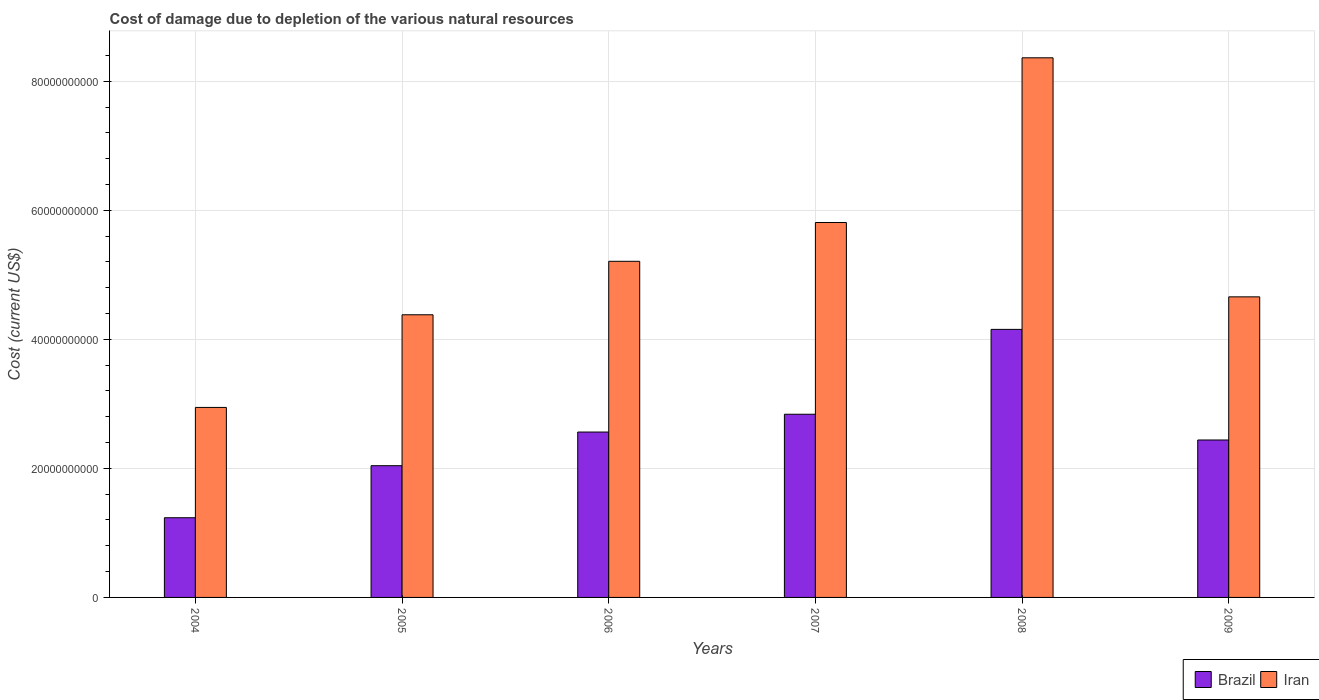How many bars are there on the 5th tick from the left?
Provide a succinct answer. 2. What is the label of the 2nd group of bars from the left?
Offer a terse response. 2005. In how many cases, is the number of bars for a given year not equal to the number of legend labels?
Offer a terse response. 0. What is the cost of damage caused due to the depletion of various natural resources in Brazil in 2008?
Your answer should be very brief. 4.15e+1. Across all years, what is the maximum cost of damage caused due to the depletion of various natural resources in Iran?
Offer a very short reply. 8.36e+1. Across all years, what is the minimum cost of damage caused due to the depletion of various natural resources in Iran?
Your answer should be very brief. 2.94e+1. In which year was the cost of damage caused due to the depletion of various natural resources in Iran maximum?
Give a very brief answer. 2008. What is the total cost of damage caused due to the depletion of various natural resources in Brazil in the graph?
Make the answer very short. 1.53e+11. What is the difference between the cost of damage caused due to the depletion of various natural resources in Iran in 2005 and that in 2009?
Your answer should be compact. -2.78e+09. What is the difference between the cost of damage caused due to the depletion of various natural resources in Brazil in 2005 and the cost of damage caused due to the depletion of various natural resources in Iran in 2006?
Your answer should be very brief. -3.17e+1. What is the average cost of damage caused due to the depletion of various natural resources in Iran per year?
Ensure brevity in your answer.  5.23e+1. In the year 2006, what is the difference between the cost of damage caused due to the depletion of various natural resources in Brazil and cost of damage caused due to the depletion of various natural resources in Iran?
Offer a very short reply. -2.65e+1. In how many years, is the cost of damage caused due to the depletion of various natural resources in Iran greater than 28000000000 US$?
Make the answer very short. 6. What is the ratio of the cost of damage caused due to the depletion of various natural resources in Brazil in 2006 to that in 2008?
Provide a succinct answer. 0.62. What is the difference between the highest and the second highest cost of damage caused due to the depletion of various natural resources in Iran?
Offer a terse response. 2.55e+1. What is the difference between the highest and the lowest cost of damage caused due to the depletion of various natural resources in Brazil?
Offer a terse response. 2.92e+1. What does the 2nd bar from the right in 2009 represents?
Keep it short and to the point. Brazil. How many bars are there?
Your response must be concise. 12. How many years are there in the graph?
Ensure brevity in your answer.  6. What is the difference between two consecutive major ticks on the Y-axis?
Make the answer very short. 2.00e+1. Are the values on the major ticks of Y-axis written in scientific E-notation?
Your answer should be compact. No. Does the graph contain any zero values?
Ensure brevity in your answer.  No. How are the legend labels stacked?
Provide a short and direct response. Horizontal. What is the title of the graph?
Your answer should be very brief. Cost of damage due to depletion of the various natural resources. What is the label or title of the X-axis?
Your response must be concise. Years. What is the label or title of the Y-axis?
Provide a short and direct response. Cost (current US$). What is the Cost (current US$) of Brazil in 2004?
Offer a very short reply. 1.24e+1. What is the Cost (current US$) of Iran in 2004?
Your response must be concise. 2.94e+1. What is the Cost (current US$) in Brazil in 2005?
Keep it short and to the point. 2.04e+1. What is the Cost (current US$) of Iran in 2005?
Make the answer very short. 4.38e+1. What is the Cost (current US$) of Brazil in 2006?
Your answer should be compact. 2.56e+1. What is the Cost (current US$) in Iran in 2006?
Your answer should be compact. 5.21e+1. What is the Cost (current US$) of Brazil in 2007?
Your answer should be compact. 2.84e+1. What is the Cost (current US$) in Iran in 2007?
Your answer should be compact. 5.81e+1. What is the Cost (current US$) in Brazil in 2008?
Offer a terse response. 4.15e+1. What is the Cost (current US$) in Iran in 2008?
Your response must be concise. 8.36e+1. What is the Cost (current US$) of Brazil in 2009?
Provide a succinct answer. 2.44e+1. What is the Cost (current US$) in Iran in 2009?
Make the answer very short. 4.66e+1. Across all years, what is the maximum Cost (current US$) of Brazil?
Offer a very short reply. 4.15e+1. Across all years, what is the maximum Cost (current US$) in Iran?
Ensure brevity in your answer.  8.36e+1. Across all years, what is the minimum Cost (current US$) of Brazil?
Keep it short and to the point. 1.24e+1. Across all years, what is the minimum Cost (current US$) of Iran?
Offer a very short reply. 2.94e+1. What is the total Cost (current US$) in Brazil in the graph?
Offer a terse response. 1.53e+11. What is the total Cost (current US$) in Iran in the graph?
Keep it short and to the point. 3.14e+11. What is the difference between the Cost (current US$) in Brazil in 2004 and that in 2005?
Your response must be concise. -8.07e+09. What is the difference between the Cost (current US$) in Iran in 2004 and that in 2005?
Offer a very short reply. -1.44e+1. What is the difference between the Cost (current US$) in Brazil in 2004 and that in 2006?
Make the answer very short. -1.33e+1. What is the difference between the Cost (current US$) in Iran in 2004 and that in 2006?
Your answer should be compact. -2.26e+1. What is the difference between the Cost (current US$) of Brazil in 2004 and that in 2007?
Ensure brevity in your answer.  -1.60e+1. What is the difference between the Cost (current US$) of Iran in 2004 and that in 2007?
Your answer should be very brief. -2.87e+1. What is the difference between the Cost (current US$) in Brazil in 2004 and that in 2008?
Offer a terse response. -2.92e+1. What is the difference between the Cost (current US$) in Iran in 2004 and that in 2008?
Offer a very short reply. -5.42e+1. What is the difference between the Cost (current US$) in Brazil in 2004 and that in 2009?
Your response must be concise. -1.20e+1. What is the difference between the Cost (current US$) of Iran in 2004 and that in 2009?
Offer a terse response. -1.71e+1. What is the difference between the Cost (current US$) in Brazil in 2005 and that in 2006?
Make the answer very short. -5.22e+09. What is the difference between the Cost (current US$) in Iran in 2005 and that in 2006?
Provide a short and direct response. -8.29e+09. What is the difference between the Cost (current US$) in Brazil in 2005 and that in 2007?
Provide a succinct answer. -7.97e+09. What is the difference between the Cost (current US$) of Iran in 2005 and that in 2007?
Ensure brevity in your answer.  -1.43e+1. What is the difference between the Cost (current US$) of Brazil in 2005 and that in 2008?
Make the answer very short. -2.11e+1. What is the difference between the Cost (current US$) in Iran in 2005 and that in 2008?
Give a very brief answer. -3.98e+1. What is the difference between the Cost (current US$) in Brazil in 2005 and that in 2009?
Your answer should be very brief. -3.98e+09. What is the difference between the Cost (current US$) in Iran in 2005 and that in 2009?
Make the answer very short. -2.78e+09. What is the difference between the Cost (current US$) of Brazil in 2006 and that in 2007?
Give a very brief answer. -2.76e+09. What is the difference between the Cost (current US$) of Iran in 2006 and that in 2007?
Provide a succinct answer. -6.01e+09. What is the difference between the Cost (current US$) of Brazil in 2006 and that in 2008?
Offer a very short reply. -1.59e+1. What is the difference between the Cost (current US$) in Iran in 2006 and that in 2008?
Provide a short and direct response. -3.15e+1. What is the difference between the Cost (current US$) in Brazil in 2006 and that in 2009?
Keep it short and to the point. 1.23e+09. What is the difference between the Cost (current US$) of Iran in 2006 and that in 2009?
Your response must be concise. 5.51e+09. What is the difference between the Cost (current US$) in Brazil in 2007 and that in 2008?
Your answer should be very brief. -1.32e+1. What is the difference between the Cost (current US$) of Iran in 2007 and that in 2008?
Your answer should be compact. -2.55e+1. What is the difference between the Cost (current US$) of Brazil in 2007 and that in 2009?
Your answer should be very brief. 3.99e+09. What is the difference between the Cost (current US$) of Iran in 2007 and that in 2009?
Offer a terse response. 1.15e+1. What is the difference between the Cost (current US$) of Brazil in 2008 and that in 2009?
Ensure brevity in your answer.  1.71e+1. What is the difference between the Cost (current US$) in Iran in 2008 and that in 2009?
Offer a terse response. 3.70e+1. What is the difference between the Cost (current US$) in Brazil in 2004 and the Cost (current US$) in Iran in 2005?
Provide a short and direct response. -3.15e+1. What is the difference between the Cost (current US$) of Brazil in 2004 and the Cost (current US$) of Iran in 2006?
Make the answer very short. -3.97e+1. What is the difference between the Cost (current US$) of Brazil in 2004 and the Cost (current US$) of Iran in 2007?
Provide a short and direct response. -4.58e+1. What is the difference between the Cost (current US$) in Brazil in 2004 and the Cost (current US$) in Iran in 2008?
Your answer should be very brief. -7.13e+1. What is the difference between the Cost (current US$) in Brazil in 2004 and the Cost (current US$) in Iran in 2009?
Make the answer very short. -3.42e+1. What is the difference between the Cost (current US$) of Brazil in 2005 and the Cost (current US$) of Iran in 2006?
Provide a short and direct response. -3.17e+1. What is the difference between the Cost (current US$) in Brazil in 2005 and the Cost (current US$) in Iran in 2007?
Your answer should be very brief. -3.77e+1. What is the difference between the Cost (current US$) in Brazil in 2005 and the Cost (current US$) in Iran in 2008?
Give a very brief answer. -6.32e+1. What is the difference between the Cost (current US$) in Brazil in 2005 and the Cost (current US$) in Iran in 2009?
Provide a succinct answer. -2.62e+1. What is the difference between the Cost (current US$) of Brazil in 2006 and the Cost (current US$) of Iran in 2007?
Provide a short and direct response. -3.25e+1. What is the difference between the Cost (current US$) in Brazil in 2006 and the Cost (current US$) in Iran in 2008?
Provide a succinct answer. -5.80e+1. What is the difference between the Cost (current US$) of Brazil in 2006 and the Cost (current US$) of Iran in 2009?
Provide a succinct answer. -2.09e+1. What is the difference between the Cost (current US$) of Brazil in 2007 and the Cost (current US$) of Iran in 2008?
Provide a short and direct response. -5.52e+1. What is the difference between the Cost (current US$) of Brazil in 2007 and the Cost (current US$) of Iran in 2009?
Your answer should be compact. -1.82e+1. What is the difference between the Cost (current US$) of Brazil in 2008 and the Cost (current US$) of Iran in 2009?
Offer a very short reply. -5.04e+09. What is the average Cost (current US$) of Brazil per year?
Your answer should be very brief. 2.55e+1. What is the average Cost (current US$) in Iran per year?
Offer a very short reply. 5.23e+1. In the year 2004, what is the difference between the Cost (current US$) in Brazil and Cost (current US$) in Iran?
Provide a succinct answer. -1.71e+1. In the year 2005, what is the difference between the Cost (current US$) in Brazil and Cost (current US$) in Iran?
Offer a terse response. -2.34e+1. In the year 2006, what is the difference between the Cost (current US$) in Brazil and Cost (current US$) in Iran?
Give a very brief answer. -2.65e+1. In the year 2007, what is the difference between the Cost (current US$) in Brazil and Cost (current US$) in Iran?
Keep it short and to the point. -2.97e+1. In the year 2008, what is the difference between the Cost (current US$) of Brazil and Cost (current US$) of Iran?
Ensure brevity in your answer.  -4.21e+1. In the year 2009, what is the difference between the Cost (current US$) of Brazil and Cost (current US$) of Iran?
Keep it short and to the point. -2.22e+1. What is the ratio of the Cost (current US$) of Brazil in 2004 to that in 2005?
Your answer should be very brief. 0.6. What is the ratio of the Cost (current US$) of Iran in 2004 to that in 2005?
Provide a succinct answer. 0.67. What is the ratio of the Cost (current US$) of Brazil in 2004 to that in 2006?
Keep it short and to the point. 0.48. What is the ratio of the Cost (current US$) in Iran in 2004 to that in 2006?
Provide a succinct answer. 0.57. What is the ratio of the Cost (current US$) in Brazil in 2004 to that in 2007?
Keep it short and to the point. 0.43. What is the ratio of the Cost (current US$) of Iran in 2004 to that in 2007?
Offer a terse response. 0.51. What is the ratio of the Cost (current US$) in Brazil in 2004 to that in 2008?
Keep it short and to the point. 0.3. What is the ratio of the Cost (current US$) of Iran in 2004 to that in 2008?
Ensure brevity in your answer.  0.35. What is the ratio of the Cost (current US$) in Brazil in 2004 to that in 2009?
Provide a succinct answer. 0.51. What is the ratio of the Cost (current US$) of Iran in 2004 to that in 2009?
Offer a terse response. 0.63. What is the ratio of the Cost (current US$) of Brazil in 2005 to that in 2006?
Provide a succinct answer. 0.8. What is the ratio of the Cost (current US$) of Iran in 2005 to that in 2006?
Give a very brief answer. 0.84. What is the ratio of the Cost (current US$) of Brazil in 2005 to that in 2007?
Offer a very short reply. 0.72. What is the ratio of the Cost (current US$) in Iran in 2005 to that in 2007?
Offer a terse response. 0.75. What is the ratio of the Cost (current US$) in Brazil in 2005 to that in 2008?
Ensure brevity in your answer.  0.49. What is the ratio of the Cost (current US$) of Iran in 2005 to that in 2008?
Your answer should be compact. 0.52. What is the ratio of the Cost (current US$) of Brazil in 2005 to that in 2009?
Ensure brevity in your answer.  0.84. What is the ratio of the Cost (current US$) in Iran in 2005 to that in 2009?
Your answer should be very brief. 0.94. What is the ratio of the Cost (current US$) in Brazil in 2006 to that in 2007?
Make the answer very short. 0.9. What is the ratio of the Cost (current US$) in Iran in 2006 to that in 2007?
Offer a terse response. 0.9. What is the ratio of the Cost (current US$) in Brazil in 2006 to that in 2008?
Ensure brevity in your answer.  0.62. What is the ratio of the Cost (current US$) of Iran in 2006 to that in 2008?
Your response must be concise. 0.62. What is the ratio of the Cost (current US$) of Brazil in 2006 to that in 2009?
Offer a terse response. 1.05. What is the ratio of the Cost (current US$) in Iran in 2006 to that in 2009?
Ensure brevity in your answer.  1.12. What is the ratio of the Cost (current US$) in Brazil in 2007 to that in 2008?
Provide a succinct answer. 0.68. What is the ratio of the Cost (current US$) of Iran in 2007 to that in 2008?
Make the answer very short. 0.69. What is the ratio of the Cost (current US$) in Brazil in 2007 to that in 2009?
Keep it short and to the point. 1.16. What is the ratio of the Cost (current US$) of Iran in 2007 to that in 2009?
Your response must be concise. 1.25. What is the ratio of the Cost (current US$) of Brazil in 2008 to that in 2009?
Keep it short and to the point. 1.7. What is the ratio of the Cost (current US$) in Iran in 2008 to that in 2009?
Give a very brief answer. 1.8. What is the difference between the highest and the second highest Cost (current US$) of Brazil?
Make the answer very short. 1.32e+1. What is the difference between the highest and the second highest Cost (current US$) of Iran?
Provide a succinct answer. 2.55e+1. What is the difference between the highest and the lowest Cost (current US$) of Brazil?
Provide a succinct answer. 2.92e+1. What is the difference between the highest and the lowest Cost (current US$) in Iran?
Give a very brief answer. 5.42e+1. 